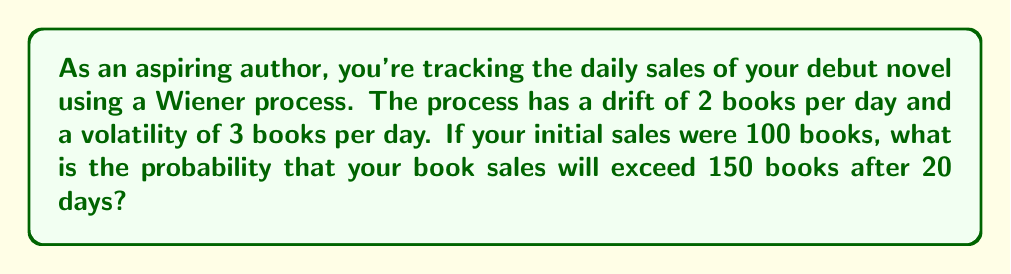Teach me how to tackle this problem. Let's approach this step-by-step using the properties of a Wiener process:

1) The Wiener process for book sales can be modeled as:

   $$ X_t = X_0 + \mu t + \sigma W_t $$

   Where:
   - $X_t$ is the number of books sold at time $t$
   - $X_0$ is the initial number of books sold (100)
   - $\mu$ is the drift (2 books/day)
   - $\sigma$ is the volatility (3 books/day)
   - $W_t$ is a standard Wiener process

2) We want to find $P(X_{20} > 150)$

3) In a Wiener process, $X_t$ follows a normal distribution with:
   - Mean: $E[X_t] = X_0 + \mu t = 100 + 2 * 20 = 140$
   - Variance: $Var(X_t) = \sigma^2 t = 3^2 * 20 = 180$

4) We can standardize this to a standard normal distribution:

   $$ Z = \frac{X_t - E[X_t]}{\sqrt{Var(X_t)}} = \frac{150 - 140}{\sqrt{180}} = \frac{10}{\sqrt{180}} \approx 0.7453 $$

5) Now we need to find $P(Z > 0.7453)$

6) Using the standard normal distribution table or a calculator, we can find:

   $P(Z > 0.7453) = 1 - P(Z < 0.7453) \approx 1 - 0.7721 = 0.2279$

Therefore, the probability that book sales will exceed 150 after 20 days is approximately 0.2279 or 22.79%.
Answer: 0.2279 